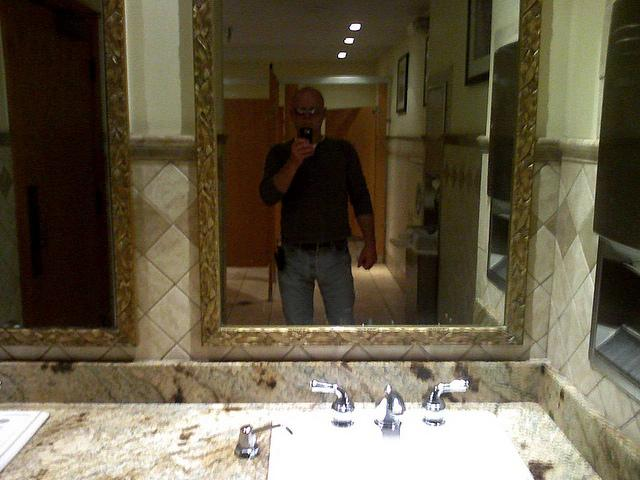Where does the man carry his cell phone? holster 